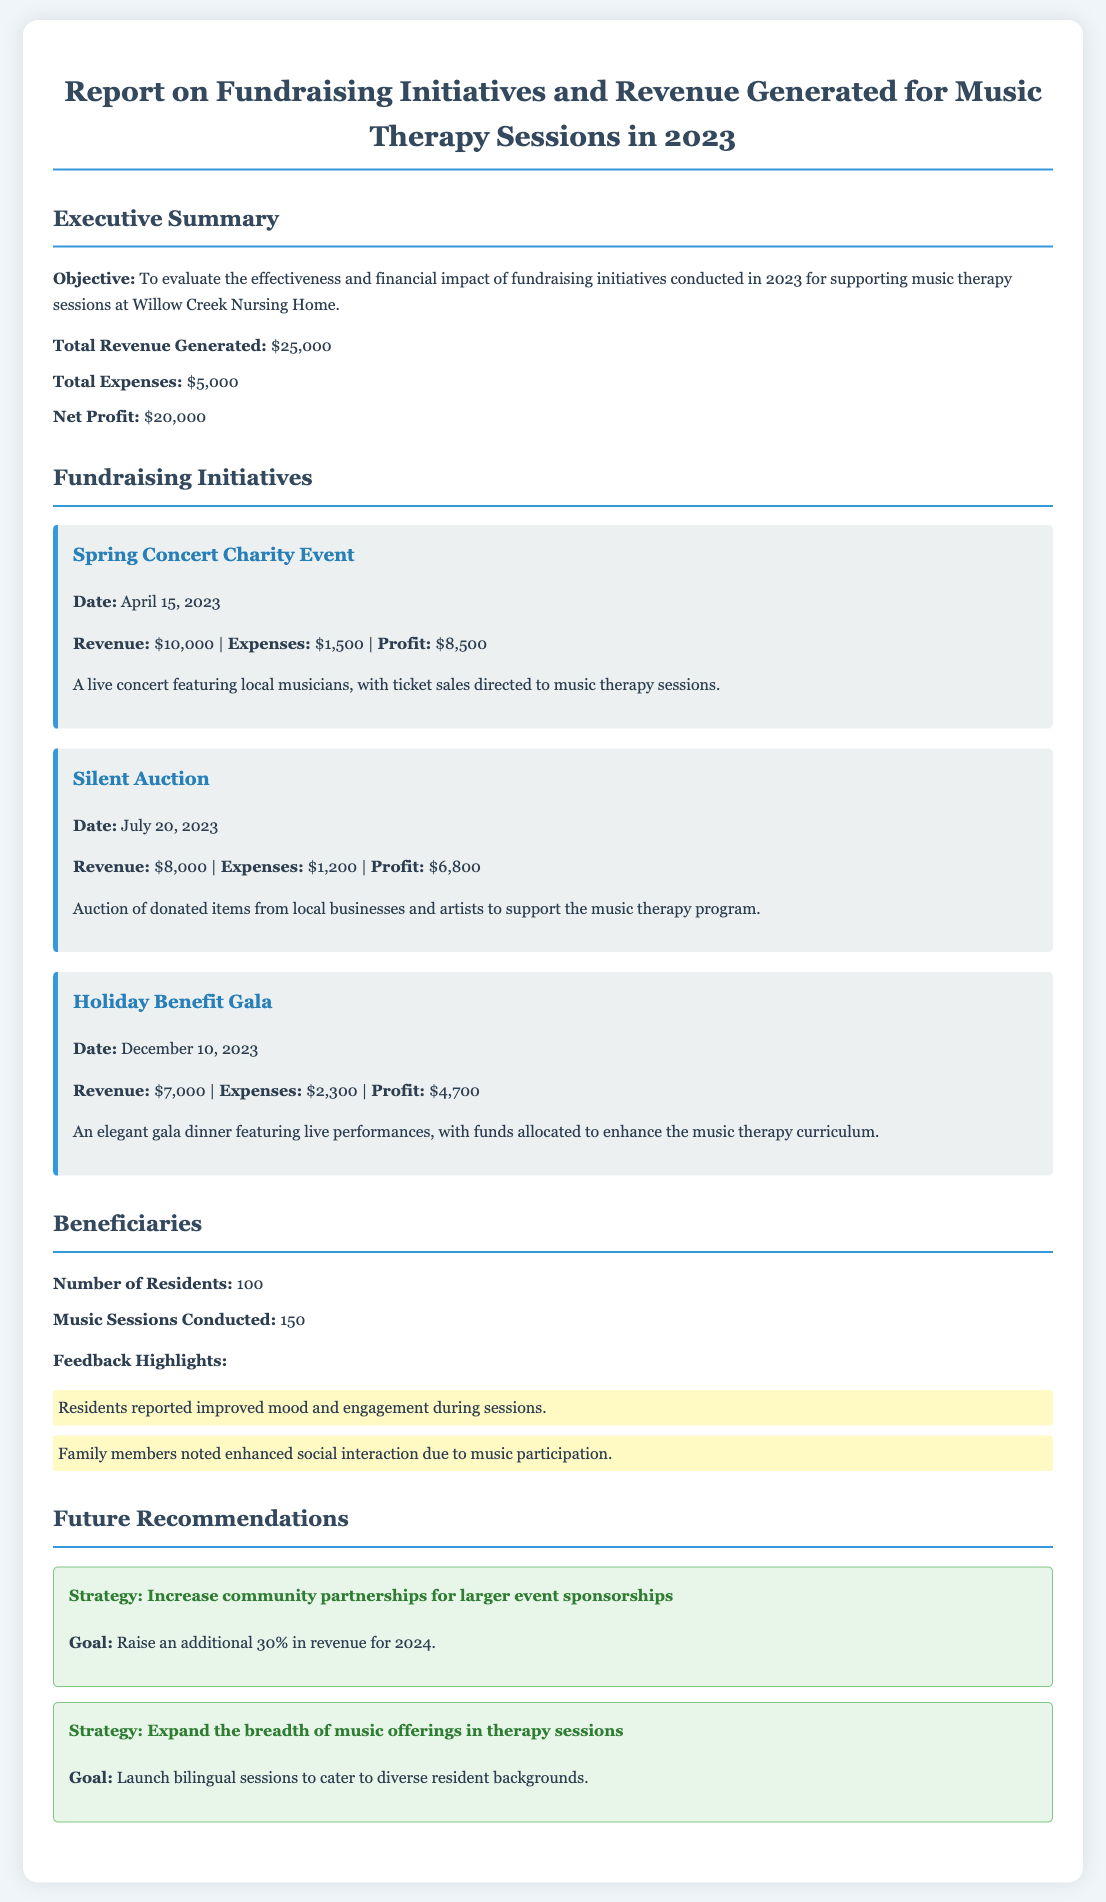what is the total revenue generated? The total revenue is mentioned in the executive summary section of the document, which states $25,000 as the total revenue generated.
Answer: $25,000 what was the profit from the Spring Concert Charity Event? The profit from the Spring Concert Charity Event is calculated by subtracting expenses from revenue, resulting in $10,000 - $1,500 = $8,500.
Answer: $8,500 how many music sessions were conducted? The document specifies that a total of 150 music sessions were conducted, which is stated in the beneficiaries section.
Answer: 150 what is the date of the Holiday Benefit Gala? The Holiday Benefit Gala took place on December 10, 2023, which is noted in the fundraising initiatives section.
Answer: December 10, 2023 what is the goal for increasing revenue in 2024? The recommendation section articulates a goal of raising an additional 30% in revenue for 2024, indicating the desired increase.
Answer: 30% how much were the total expenses for the fundraising initiatives? The total expenses, as provided in the executive summary, amount to $5,000.
Answer: $5,000 what feedback highlights were noted by family members? The document lists improved social interaction due to music participation as feedback from family members in the beneficiaries section.
Answer: Enhanced social interaction what was the revenue generated by the Silent Auction? The revenue from the Silent Auction is specified as $8,000 in the fundraising initiatives section.
Answer: $8,000 